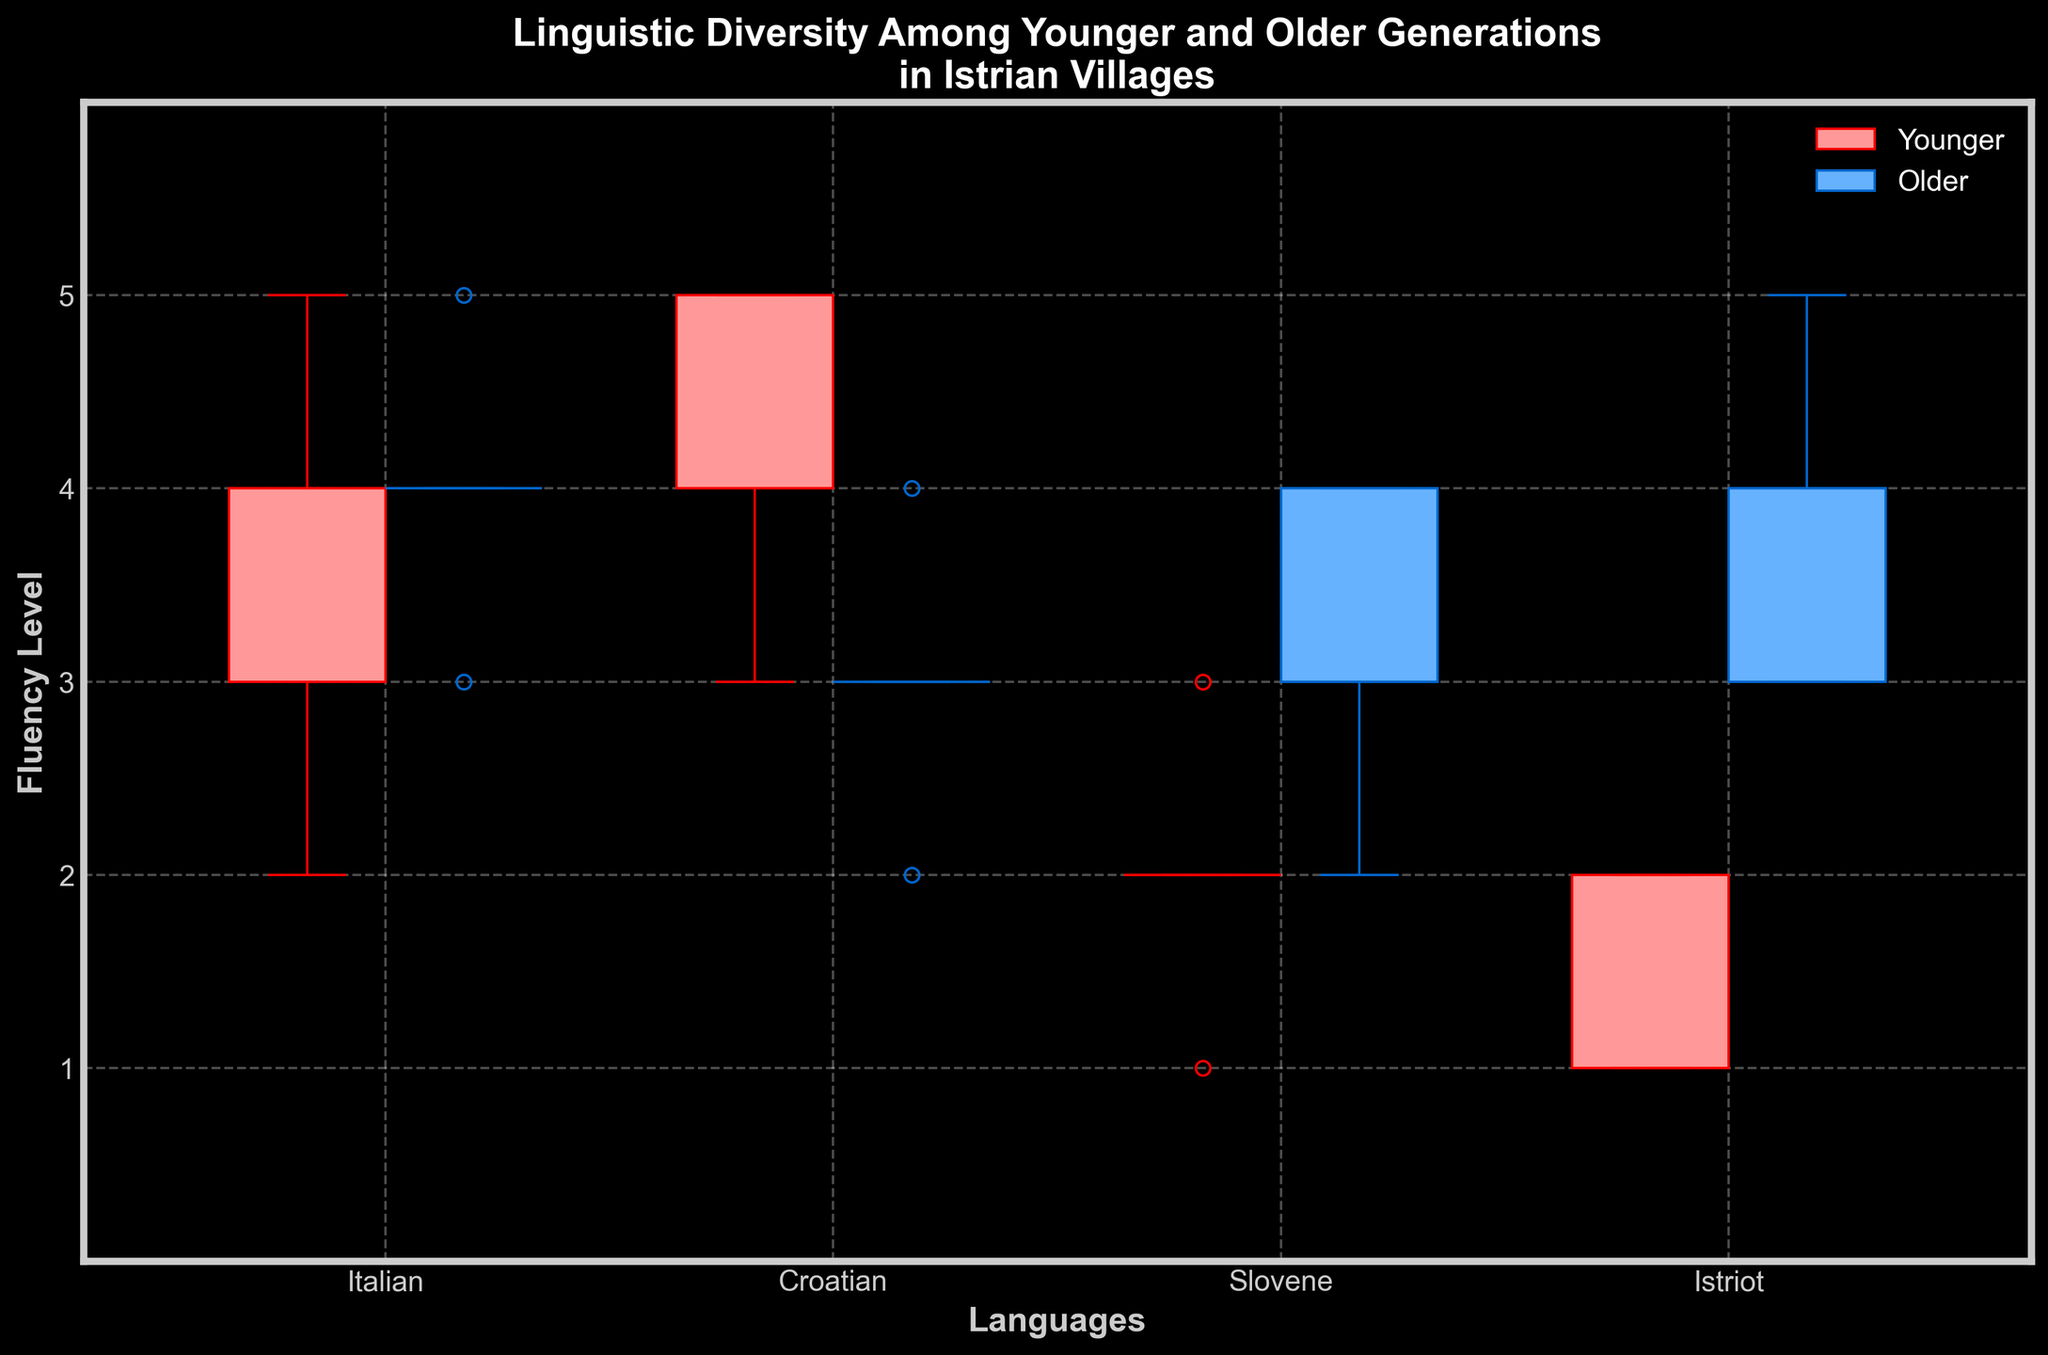What is the title of the figure? The title of the figure is displayed at the top of the plot. It reads, "Linguistic Diversity Among Younger and Older Generations in Istrian Villages."
Answer: Linguistic Diversity Among Younger and Older Generations in Istrian Villages Which generation has a higher median fluency level in Croatian? The median fluency level for the two generations can be identified by the line within each box. The median line for the older generation (blue box) in Croatian is at 3, and the younger generation (red box) is at 4.
Answer: Younger What is the range of fluency levels for the younger generation in Slovene? The range is determined by the whiskers, which are the lines extending from the box. For the younger generation in Slovene, the whiskers extend from 1 to 3.
Answer: 1 to 3 Which language shows the most significant difference in median fluency levels between the two generations? The median lines inside the boxes should be compared. Istriot shows the most notable difference: the median for the younger generation is around 1.5, and the older generation's median is around 3.
Answer: Istriot Are there any outliers in the fluency levels for the older generation in any language? Outliers are shown as individual points outside the whiskers. Reviewing the plot, there are no points located outside the whiskers for the older generation in any language.
Answer: No What's the average median fluency level across all languages for the younger generation? The median fluency levels for the younger generation in each language are: Italian (4), Croatian (4), Slovene (2), Istriot (1.5). Summing these medians: 4 + 4 + 2 + 1.5 = 11.5. Dividing by 4 gives the average median: 11.5 / 4 = 2.875.
Answer: 2.875 Which language has the least variation in fluency levels for the older generation? Variation is shown by the interquartile range (IQR), represented by the height of the boxes. Slovene has the smallest IQR, indicating the least variation.
Answer: Slovene For which language do younger generations have a smaller interquartile range (IQR) than the older generation? The IQR is indicated by the height of the box. Comparing both generations, Croatian shows a smaller IQR for the younger generation than for the older generation.
Answer: Croatian For which language do both generations have the same min and max fluency levels? Both the minimum and the maximum can be identified by the whiskers. Both generations in Italian have the same min (3) and max (5) fluency levels.
Answer: Italian 